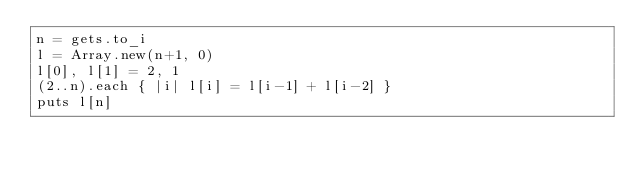Convert code to text. <code><loc_0><loc_0><loc_500><loc_500><_Ruby_>n = gets.to_i
l = Array.new(n+1, 0)
l[0], l[1] = 2, 1
(2..n).each { |i| l[i] = l[i-1] + l[i-2] }
puts l[n]
</code> 